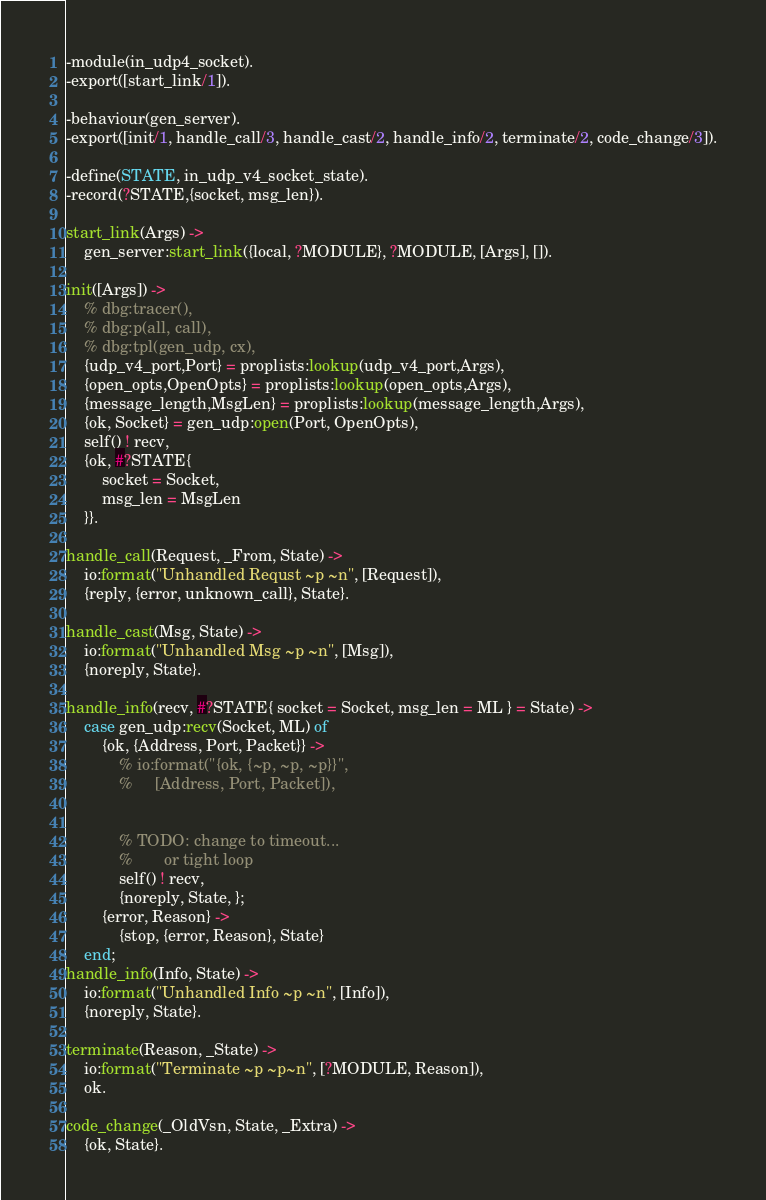<code> <loc_0><loc_0><loc_500><loc_500><_Erlang_>-module(in_udp4_socket).
-export([start_link/1]).

-behaviour(gen_server).
-export([init/1, handle_call/3, handle_cast/2, handle_info/2, terminate/2, code_change/3]).

-define(STATE, in_udp_v4_socket_state).
-record(?STATE,{socket, msg_len}).

start_link(Args) ->
    gen_server:start_link({local, ?MODULE}, ?MODULE, [Args], []).

init([Args]) ->
    % dbg:tracer(),
    % dbg:p(all, call),
    % dbg:tpl(gen_udp, cx),
    {udp_v4_port,Port} = proplists:lookup(udp_v4_port,Args),
    {open_opts,OpenOpts} = proplists:lookup(open_opts,Args),
    {message_length,MsgLen} = proplists:lookup(message_length,Args),
    {ok, Socket} = gen_udp:open(Port, OpenOpts),
    self() ! recv,
    {ok, #?STATE{
        socket = Socket,
        msg_len = MsgLen
    }}.

handle_call(Request, _From, State) ->
    io:format("Unhandled Requst ~p ~n", [Request]),
    {reply, {error, unknown_call}, State}.

handle_cast(Msg, State) ->
    io:format("Unhandled Msg ~p ~n", [Msg]),
    {noreply, State}.

handle_info(recv, #?STATE{ socket = Socket, msg_len = ML } = State) ->
    case gen_udp:recv(Socket, ML) of
        {ok, {Address, Port, Packet}} ->
            % io:format("{ok, {~p, ~p, ~p}}",
            %     [Address, Port, Packet]),


            % TODO: change to timeout...
            %       or tight loop
            self() ! recv,
            {noreply, State, };
        {error, Reason} ->
            {stop, {error, Reason}, State}
    end;
handle_info(Info, State) ->
    io:format("Unhandled Info ~p ~n", [Info]),
    {noreply, State}.

terminate(Reason, _State) ->
    io:format("Terminate ~p ~p~n", [?MODULE, Reason]),
    ok.

code_change(_OldVsn, State, _Extra) ->
    {ok, State}.</code> 